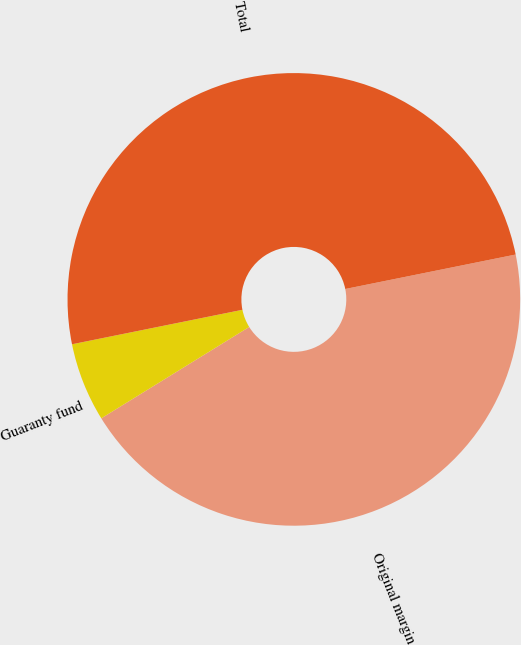Convert chart. <chart><loc_0><loc_0><loc_500><loc_500><pie_chart><fcel>Original margin<fcel>Guaranty fund<fcel>Total<nl><fcel>44.37%<fcel>5.63%<fcel>50.0%<nl></chart> 